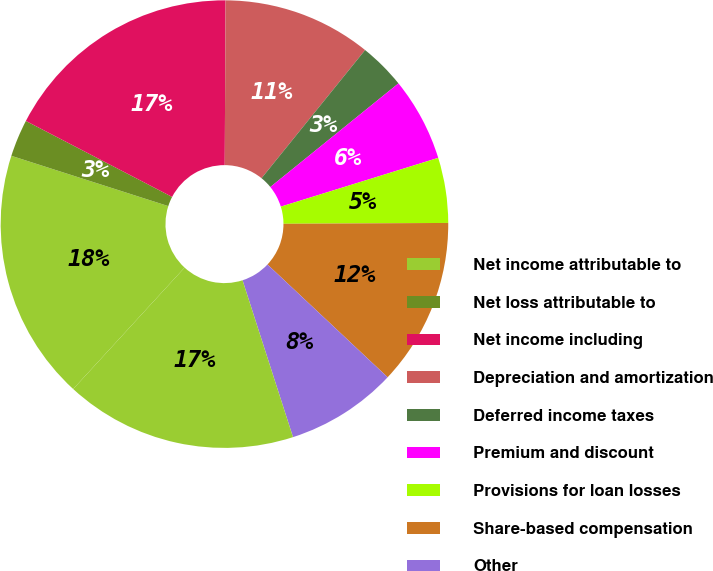<chart> <loc_0><loc_0><loc_500><loc_500><pie_chart><fcel>Net income attributable to<fcel>Net loss attributable to<fcel>Net income including<fcel>Depreciation and amortization<fcel>Deferred income taxes<fcel>Premium and discount<fcel>Provisions for loan losses<fcel>Share-based compensation<fcel>Other<fcel>Assets segregated pursuant to<nl><fcel>18.12%<fcel>2.69%<fcel>17.45%<fcel>10.74%<fcel>3.36%<fcel>6.04%<fcel>4.7%<fcel>12.08%<fcel>8.05%<fcel>16.77%<nl></chart> 